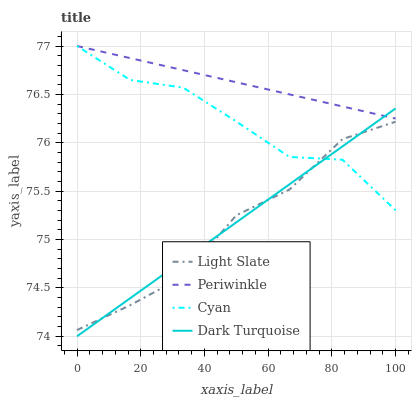Does Light Slate have the minimum area under the curve?
Answer yes or no. Yes. Does Periwinkle have the maximum area under the curve?
Answer yes or no. Yes. Does Cyan have the minimum area under the curve?
Answer yes or no. No. Does Cyan have the maximum area under the curve?
Answer yes or no. No. Is Dark Turquoise the smoothest?
Answer yes or no. Yes. Is Cyan the roughest?
Answer yes or no. Yes. Is Periwinkle the smoothest?
Answer yes or no. No. Is Periwinkle the roughest?
Answer yes or no. No. Does Dark Turquoise have the lowest value?
Answer yes or no. Yes. Does Cyan have the lowest value?
Answer yes or no. No. Does Periwinkle have the highest value?
Answer yes or no. Yes. Does Dark Turquoise have the highest value?
Answer yes or no. No. Is Light Slate less than Periwinkle?
Answer yes or no. Yes. Is Periwinkle greater than Light Slate?
Answer yes or no. Yes. Does Light Slate intersect Cyan?
Answer yes or no. Yes. Is Light Slate less than Cyan?
Answer yes or no. No. Is Light Slate greater than Cyan?
Answer yes or no. No. Does Light Slate intersect Periwinkle?
Answer yes or no. No. 